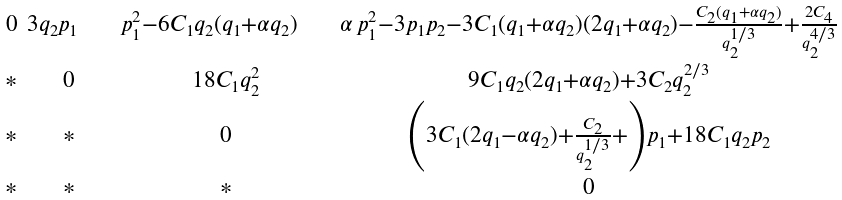Convert formula to latex. <formula><loc_0><loc_0><loc_500><loc_500>\begin{smallmatrix} 0 & 3 q _ { 2 } p _ { 1 } \quad & p _ { 1 } ^ { 2 } - 6 C _ { 1 } q _ { 2 } ( q _ { 1 } + \alpha q _ { 2 } ) \quad & \alpha \, p _ { 1 } ^ { 2 } - 3 p _ { 1 } p _ { 2 } - 3 C _ { 1 } ( q _ { 1 } + \alpha q _ { 2 } ) ( 2 q _ { 1 } + \alpha q _ { 2 } ) - \frac { C _ { 2 } ( q _ { 1 } + \alpha q _ { 2 } ) } { q _ { 2 } ^ { 1 / 3 } } + \frac { 2 C _ { 4 } } { q _ { 2 } ^ { 4 / 3 } } \\ \\ * & 0 & 1 8 C _ { 1 } q _ { 2 } ^ { 2 } & 9 C _ { 1 } q _ { 2 } ( 2 q _ { 1 } + \alpha q _ { 2 } ) + 3 C _ { 2 } q _ { 2 } ^ { 2 / 3 } \\ \\ * & * & 0 & \left ( 3 C _ { 1 } ( 2 q _ { 1 } - \alpha q _ { 2 } ) + \frac { C _ { 2 } } { q _ { 2 } ^ { 1 / 3 } } + \right ) p _ { 1 } + 1 8 C _ { 1 } q _ { 2 } p _ { 2 } \\ \\ * & * & * & 0 \end{smallmatrix}</formula> 